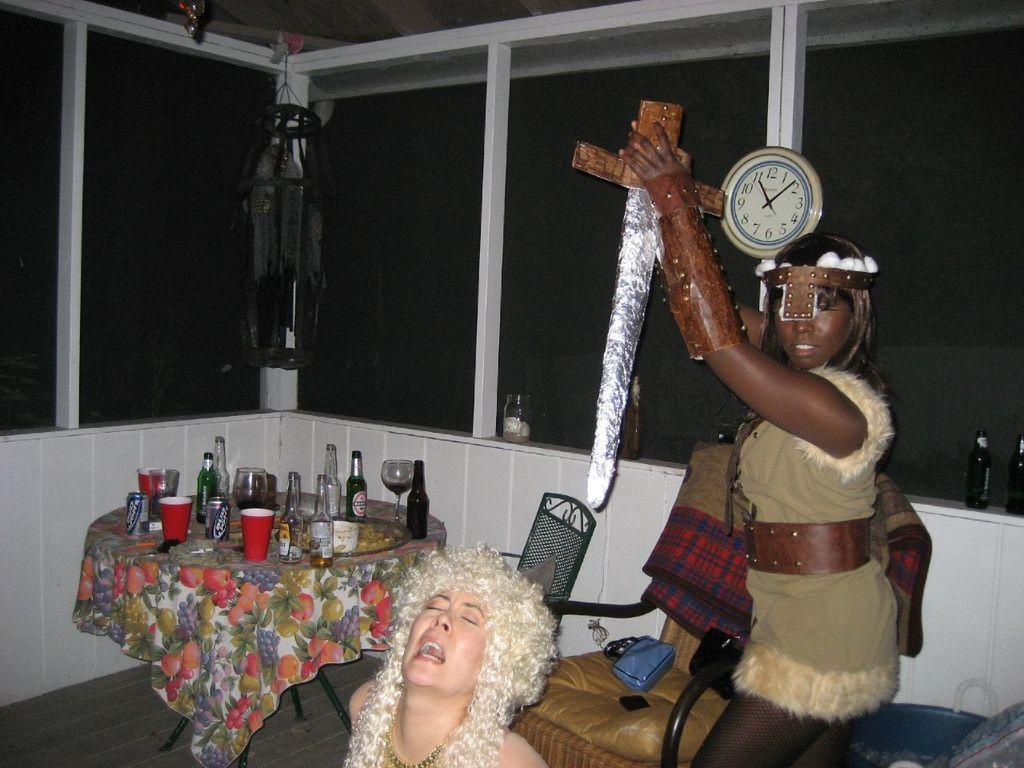<image>
Summarize the visual content of the image. A clock in a room with people dressed in costume reads about 11:10. 